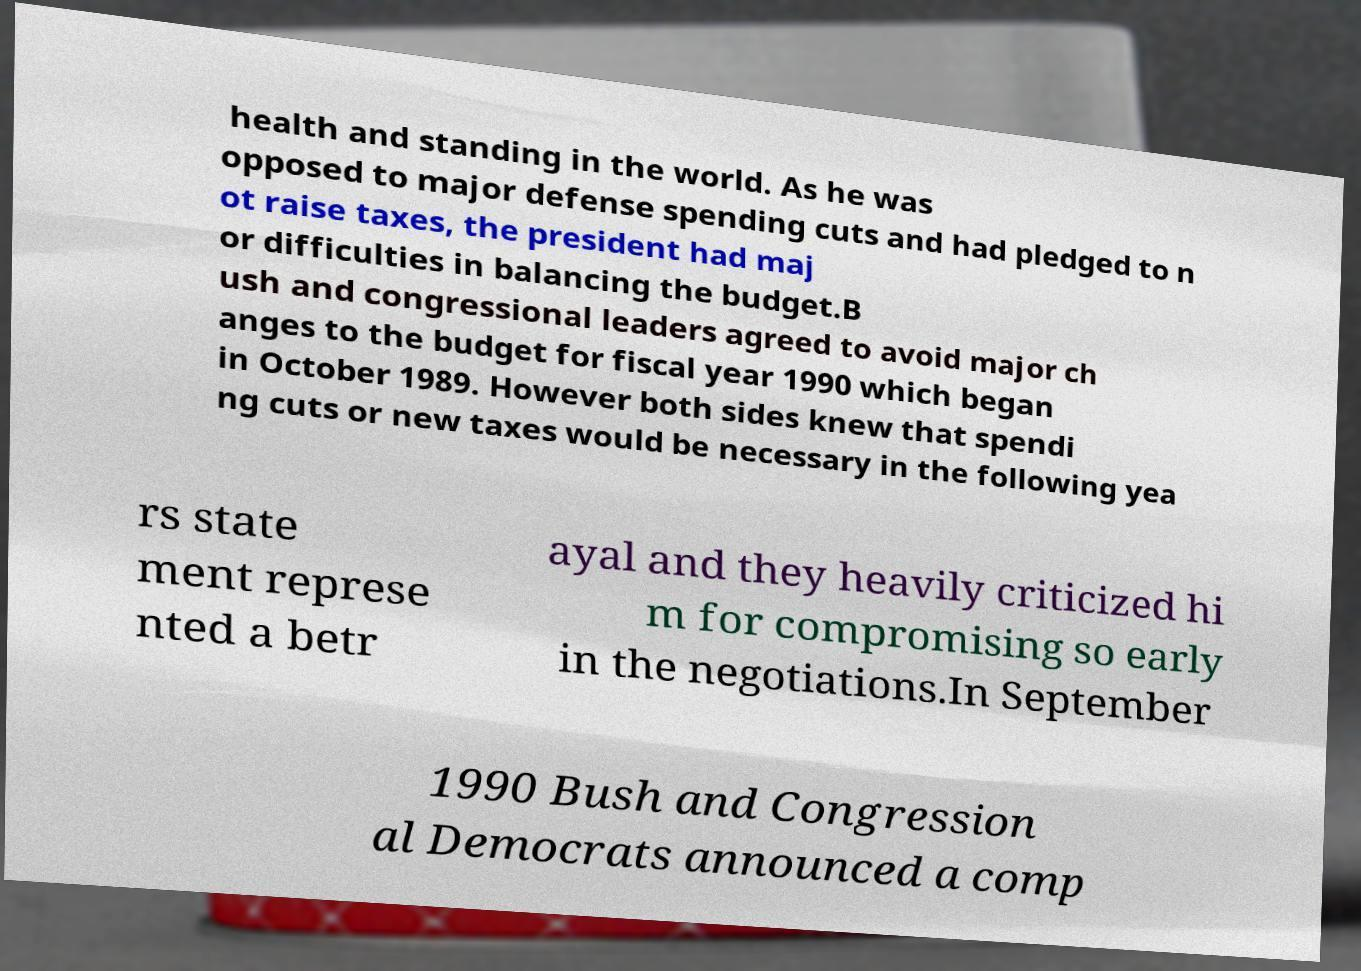Could you assist in decoding the text presented in this image and type it out clearly? health and standing in the world. As he was opposed to major defense spending cuts and had pledged to n ot raise taxes, the president had maj or difficulties in balancing the budget.B ush and congressional leaders agreed to avoid major ch anges to the budget for fiscal year 1990 which began in October 1989. However both sides knew that spendi ng cuts or new taxes would be necessary in the following yea rs state ment represe nted a betr ayal and they heavily criticized hi m for compromising so early in the negotiations.In September 1990 Bush and Congression al Democrats announced a comp 